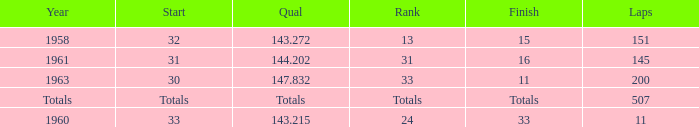Can you parse all the data within this table? {'header': ['Year', 'Start', 'Qual', 'Rank', 'Finish', 'Laps'], 'rows': [['1958', '32', '143.272', '13', '15', '151'], ['1961', '31', '144.202', '31', '16', '145'], ['1963', '30', '147.832', '33', '11', '200'], ['Totals', 'Totals', 'Totals', 'Totals', 'Totals', '507'], ['1960', '33', '143.215', '24', '33', '11']]} What year did the rank of 31 happen in? 1961.0. 